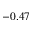<formula> <loc_0><loc_0><loc_500><loc_500>- 0 . 4 7</formula> 